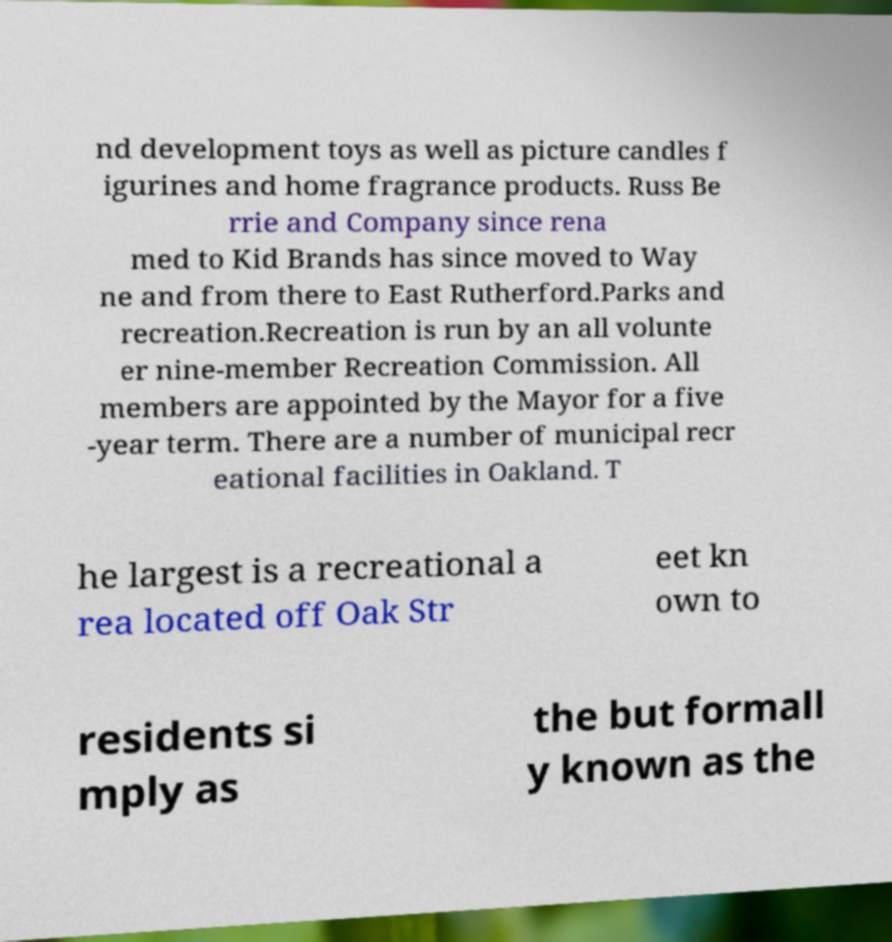Could you assist in decoding the text presented in this image and type it out clearly? nd development toys as well as picture candles f igurines and home fragrance products. Russ Be rrie and Company since rena med to Kid Brands has since moved to Way ne and from there to East Rutherford.Parks and recreation.Recreation is run by an all volunte er nine-member Recreation Commission. All members are appointed by the Mayor for a five -year term. There are a number of municipal recr eational facilities in Oakland. T he largest is a recreational a rea located off Oak Str eet kn own to residents si mply as the but formall y known as the 